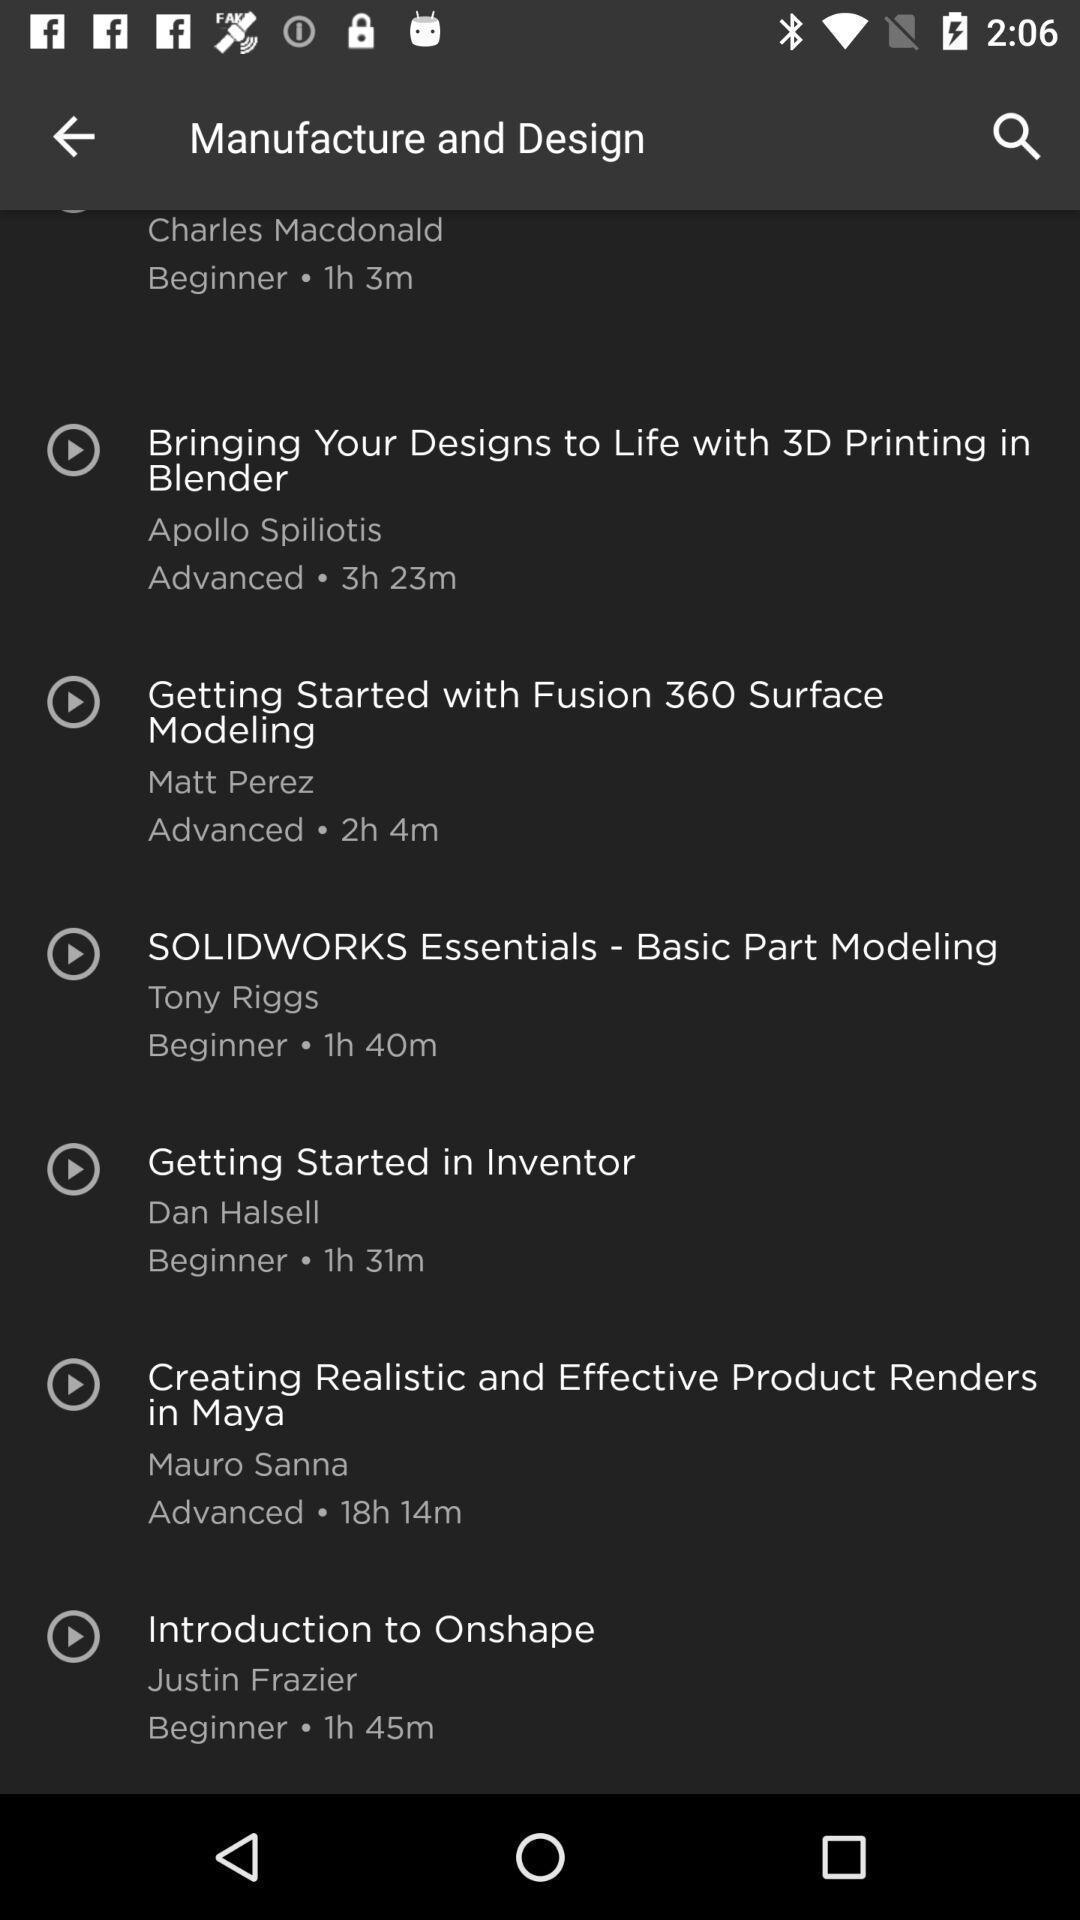Summarize the information in this screenshot. Page for the learning application with many other options. 